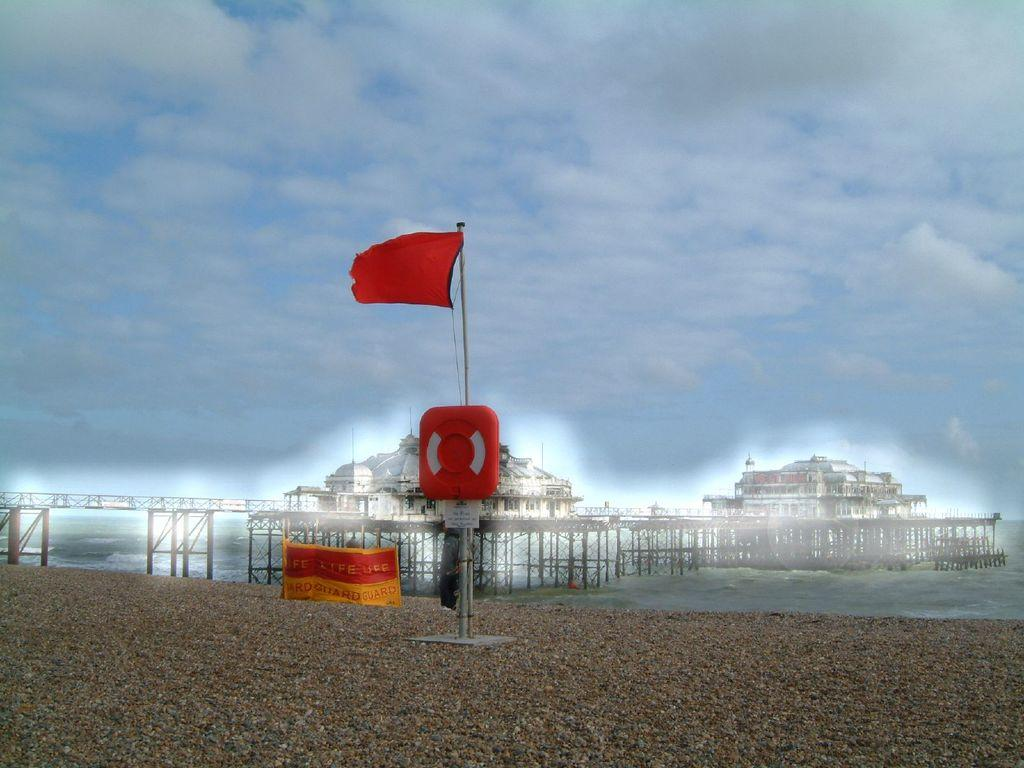What can be seen flying or waving in the image? There is a flag in the image. What objects are present that might be used for displaying information or advertisements? There are boards and a banner in the image. What structure is present that might be used for supporting the flag or banner? There is a pole in the image. What type of structure is visible in the image that allows people or vehicles to cross a body of water? There is a bridge in the image. What natural element is visible in the image? There is water visible in the image. What type of man-made structures can be seen in the image? There are buildings in the image. What is visible in the background of the image? The sky is visible in the background of the image, with clouds present. What type of cream can be seen being applied to the knee in the image? There is no cream or knee present in the image; it features a flag, boards, a pole, a banner, a bridge, water, buildings, and a sky with clouds. 